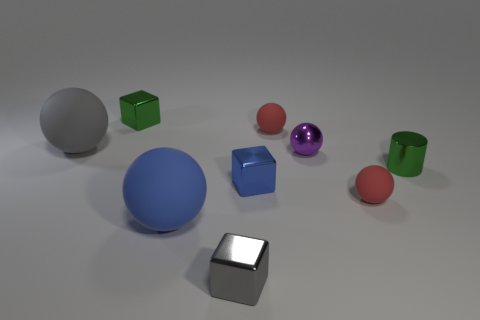Subtract all purple blocks. How many red balls are left? 2 Subtract all purple spheres. How many spheres are left? 4 Subtract 1 blocks. How many blocks are left? 2 Subtract all purple spheres. How many spheres are left? 4 Subtract all yellow balls. Subtract all yellow cylinders. How many balls are left? 5 Subtract all cylinders. How many objects are left? 8 Add 6 metallic balls. How many metallic balls exist? 7 Subtract 1 green blocks. How many objects are left? 8 Subtract all big gray spheres. Subtract all tiny spheres. How many objects are left? 5 Add 8 big matte things. How many big matte things are left? 10 